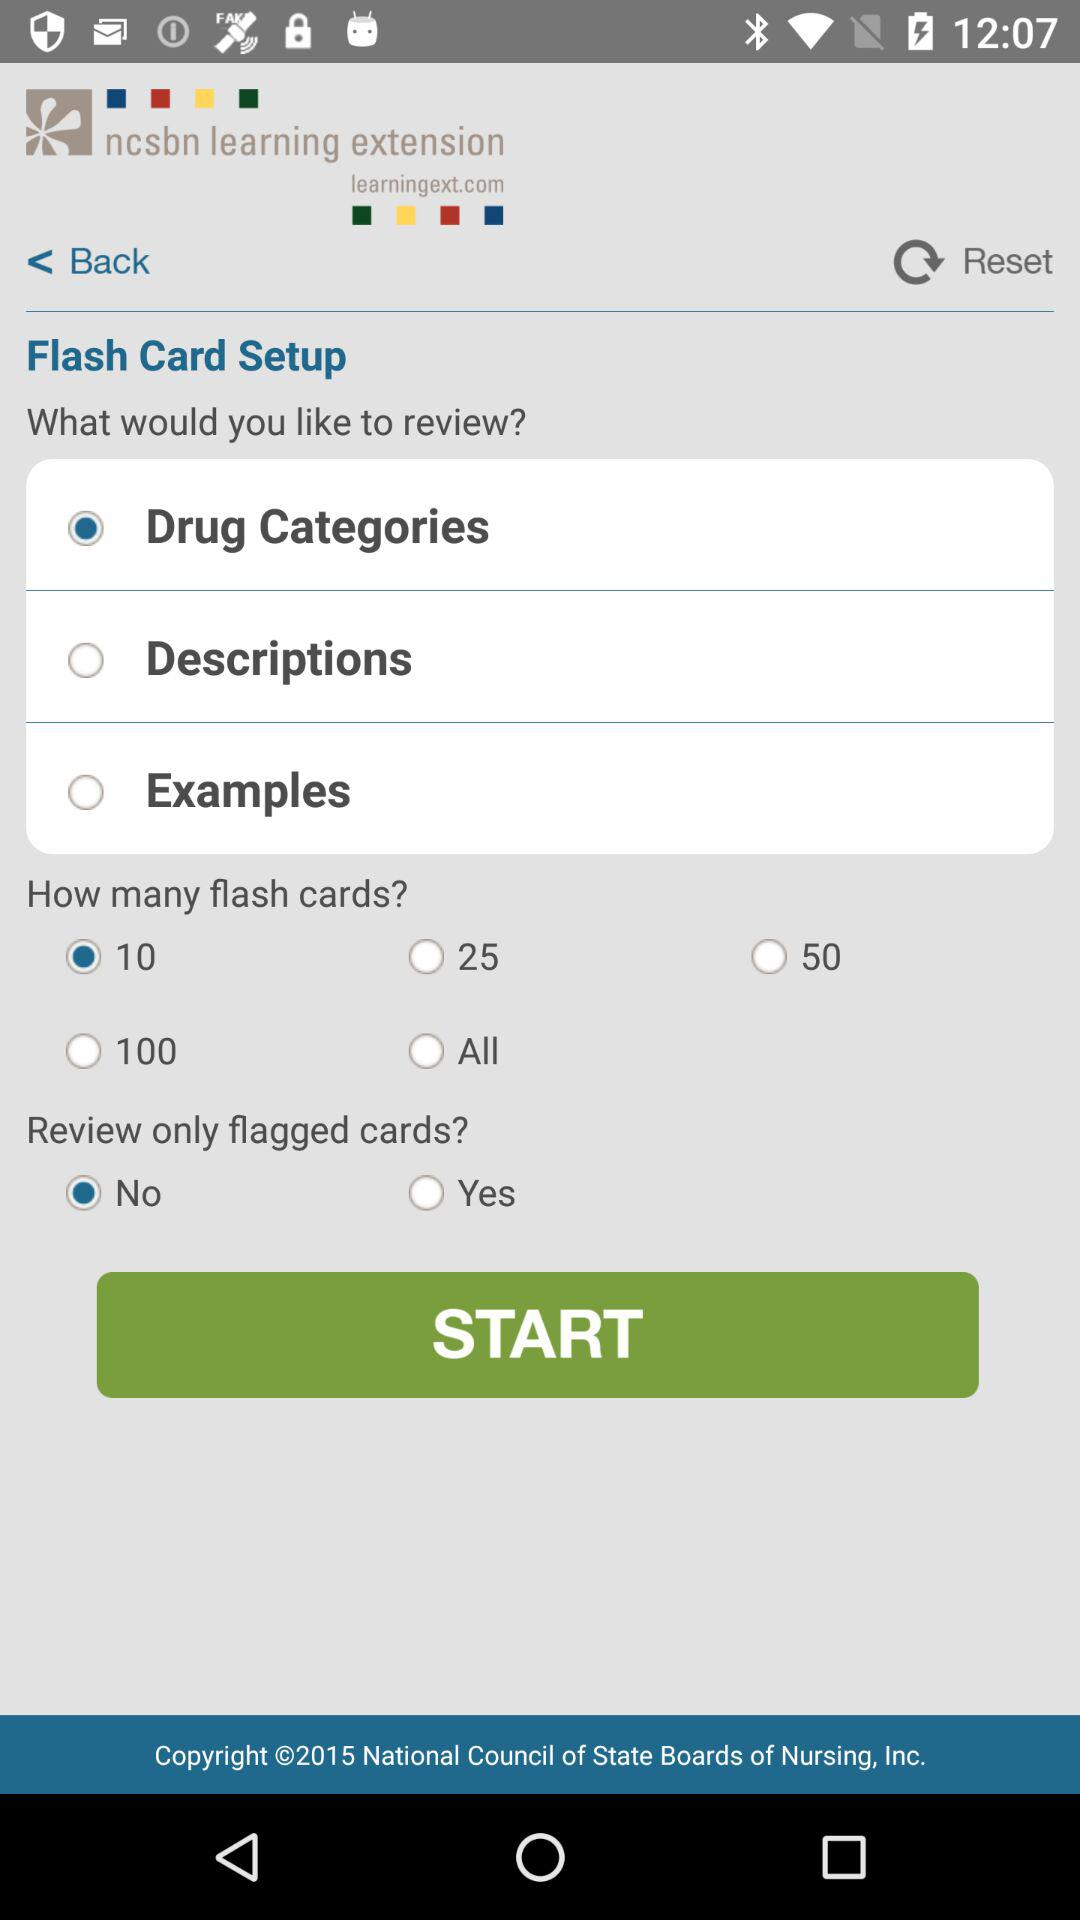What is the status of the "Review only flagged cards"? The status is "no". 